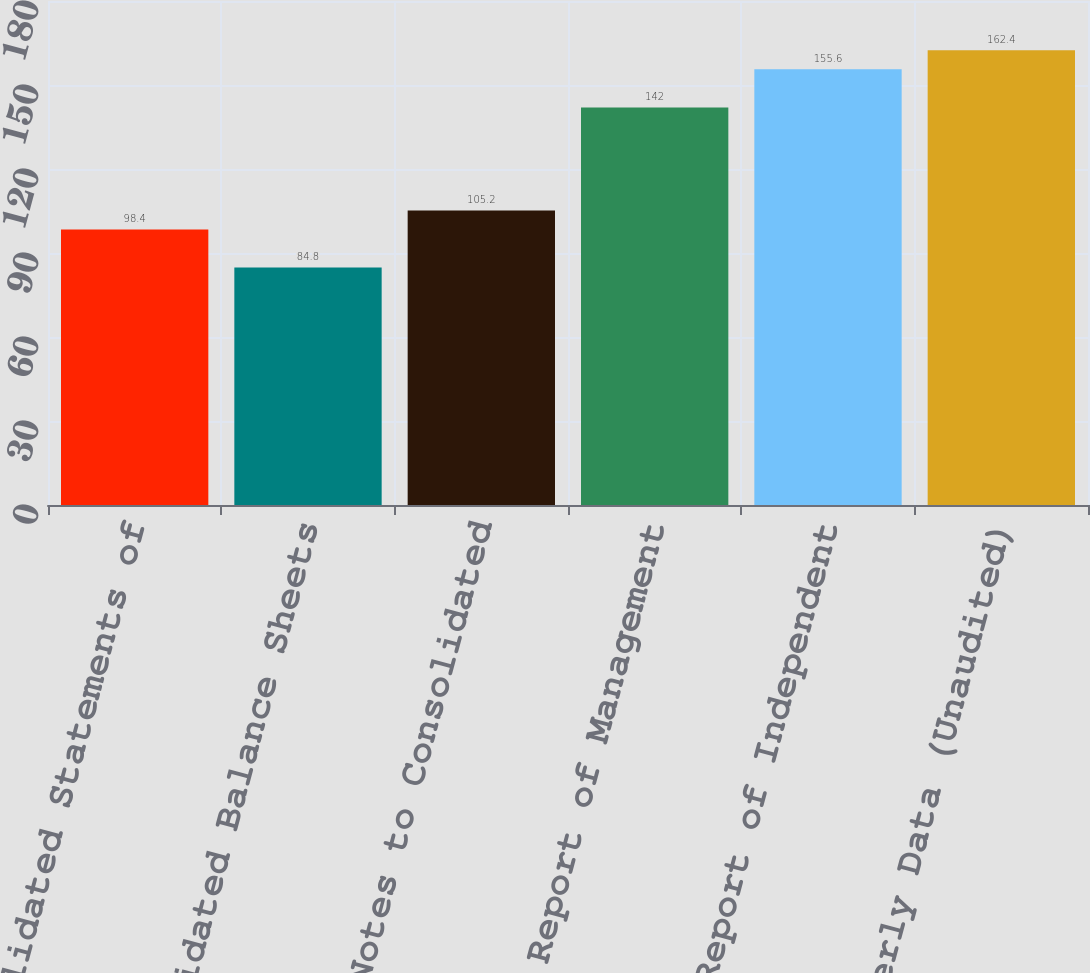<chart> <loc_0><loc_0><loc_500><loc_500><bar_chart><fcel>Consolidated Statements of<fcel>Consolidated Balance Sheets<fcel>Notes to Consolidated<fcel>Report of Management<fcel>Report of Independent<fcel>Quarterly Data (Unaudited)<nl><fcel>98.4<fcel>84.8<fcel>105.2<fcel>142<fcel>155.6<fcel>162.4<nl></chart> 